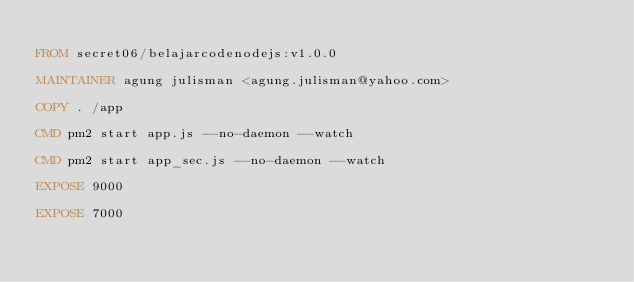<code> <loc_0><loc_0><loc_500><loc_500><_Dockerfile_>
FROM secret06/belajarcodenodejs:v1.0.0

MAINTAINER agung julisman <agung.julisman@yahoo.com>

COPY . /app

CMD pm2 start app.js --no-daemon --watch 

CMD pm2 start app_sec.js --no-daemon --watch 

EXPOSE 9000

EXPOSE 7000








</code> 